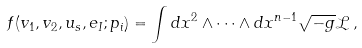Convert formula to latex. <formula><loc_0><loc_0><loc_500><loc_500>f ( v _ { 1 } , v _ { 2 } , u _ { s } , e _ { I } ; p _ { i } ) = \int d x ^ { 2 } \wedge \cdots \wedge d x ^ { n - 1 } \sqrt { - g } \mathcal { L } \, ,</formula> 